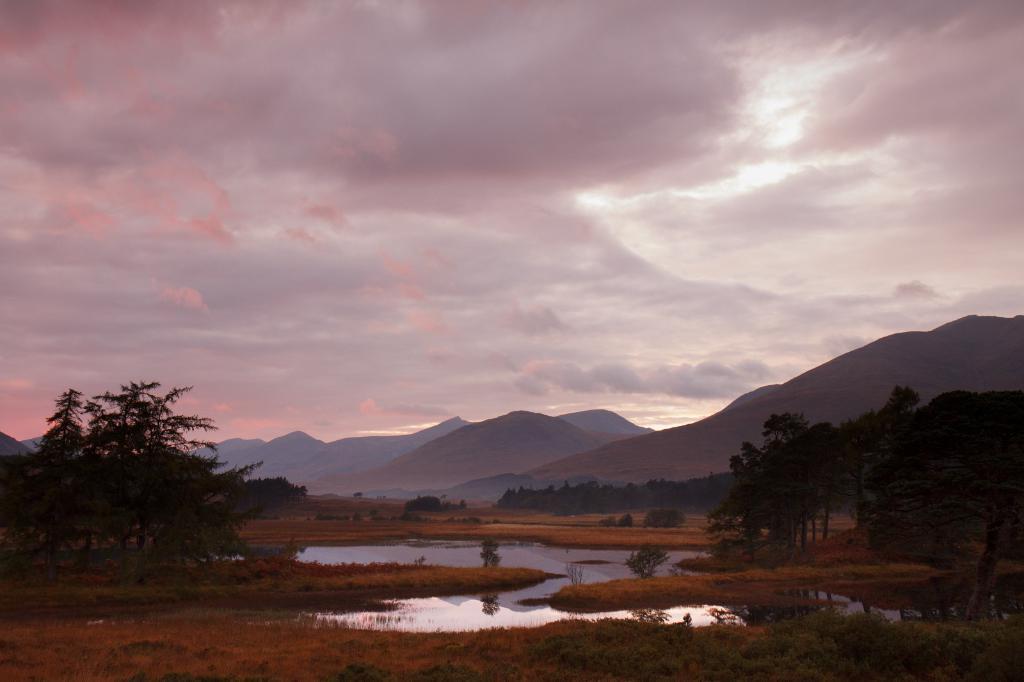Describe this image in one or two sentences. In this picture we can see grass, plants, water and trees. In the background of the image we can see hills and sky with clouds. 